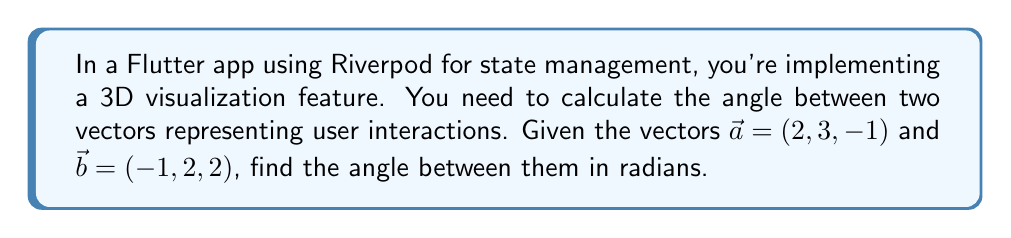Solve this math problem. To find the angle between two vectors in 3D space, we can use the dot product formula:

$$\cos \theta = \frac{\vec{a} \cdot \vec{b}}{|\vec{a}||\vec{b}|}$$

Where $\theta$ is the angle between the vectors, $\vec{a} \cdot \vec{b}$ is the dot product, and $|\vec{a}|$ and $|\vec{b}|$ are the magnitudes of the vectors.

Step 1: Calculate the dot product $\vec{a} \cdot \vec{b}$
$$\vec{a} \cdot \vec{b} = (2)(-1) + (3)(2) + (-1)(2) = -2 + 6 - 2 = 2$$

Step 2: Calculate the magnitudes of $\vec{a}$ and $\vec{b}$
$$|\vec{a}| = \sqrt{2^2 + 3^2 + (-1)^2} = \sqrt{4 + 9 + 1} = \sqrt{14}$$
$$|\vec{b}| = \sqrt{(-1)^2 + 2^2 + 2^2} = \sqrt{1 + 4 + 4} = 3$$

Step 3: Substitute the values into the formula
$$\cos \theta = \frac{2}{\sqrt{14} \cdot 3}$$

Step 4: Solve for $\theta$ using the inverse cosine (arccos) function
$$\theta = \arccos\left(\frac{2}{\sqrt{14} \cdot 3}\right)$$

Step 5: Evaluate the expression (you can use a calculator for this)
$$\theta \approx 1.249 \text{ radians}$$
Answer: $\arccos\left(\frac{2}{\sqrt{14} \cdot 3}\right) \approx 1.249 \text{ radians}$ 